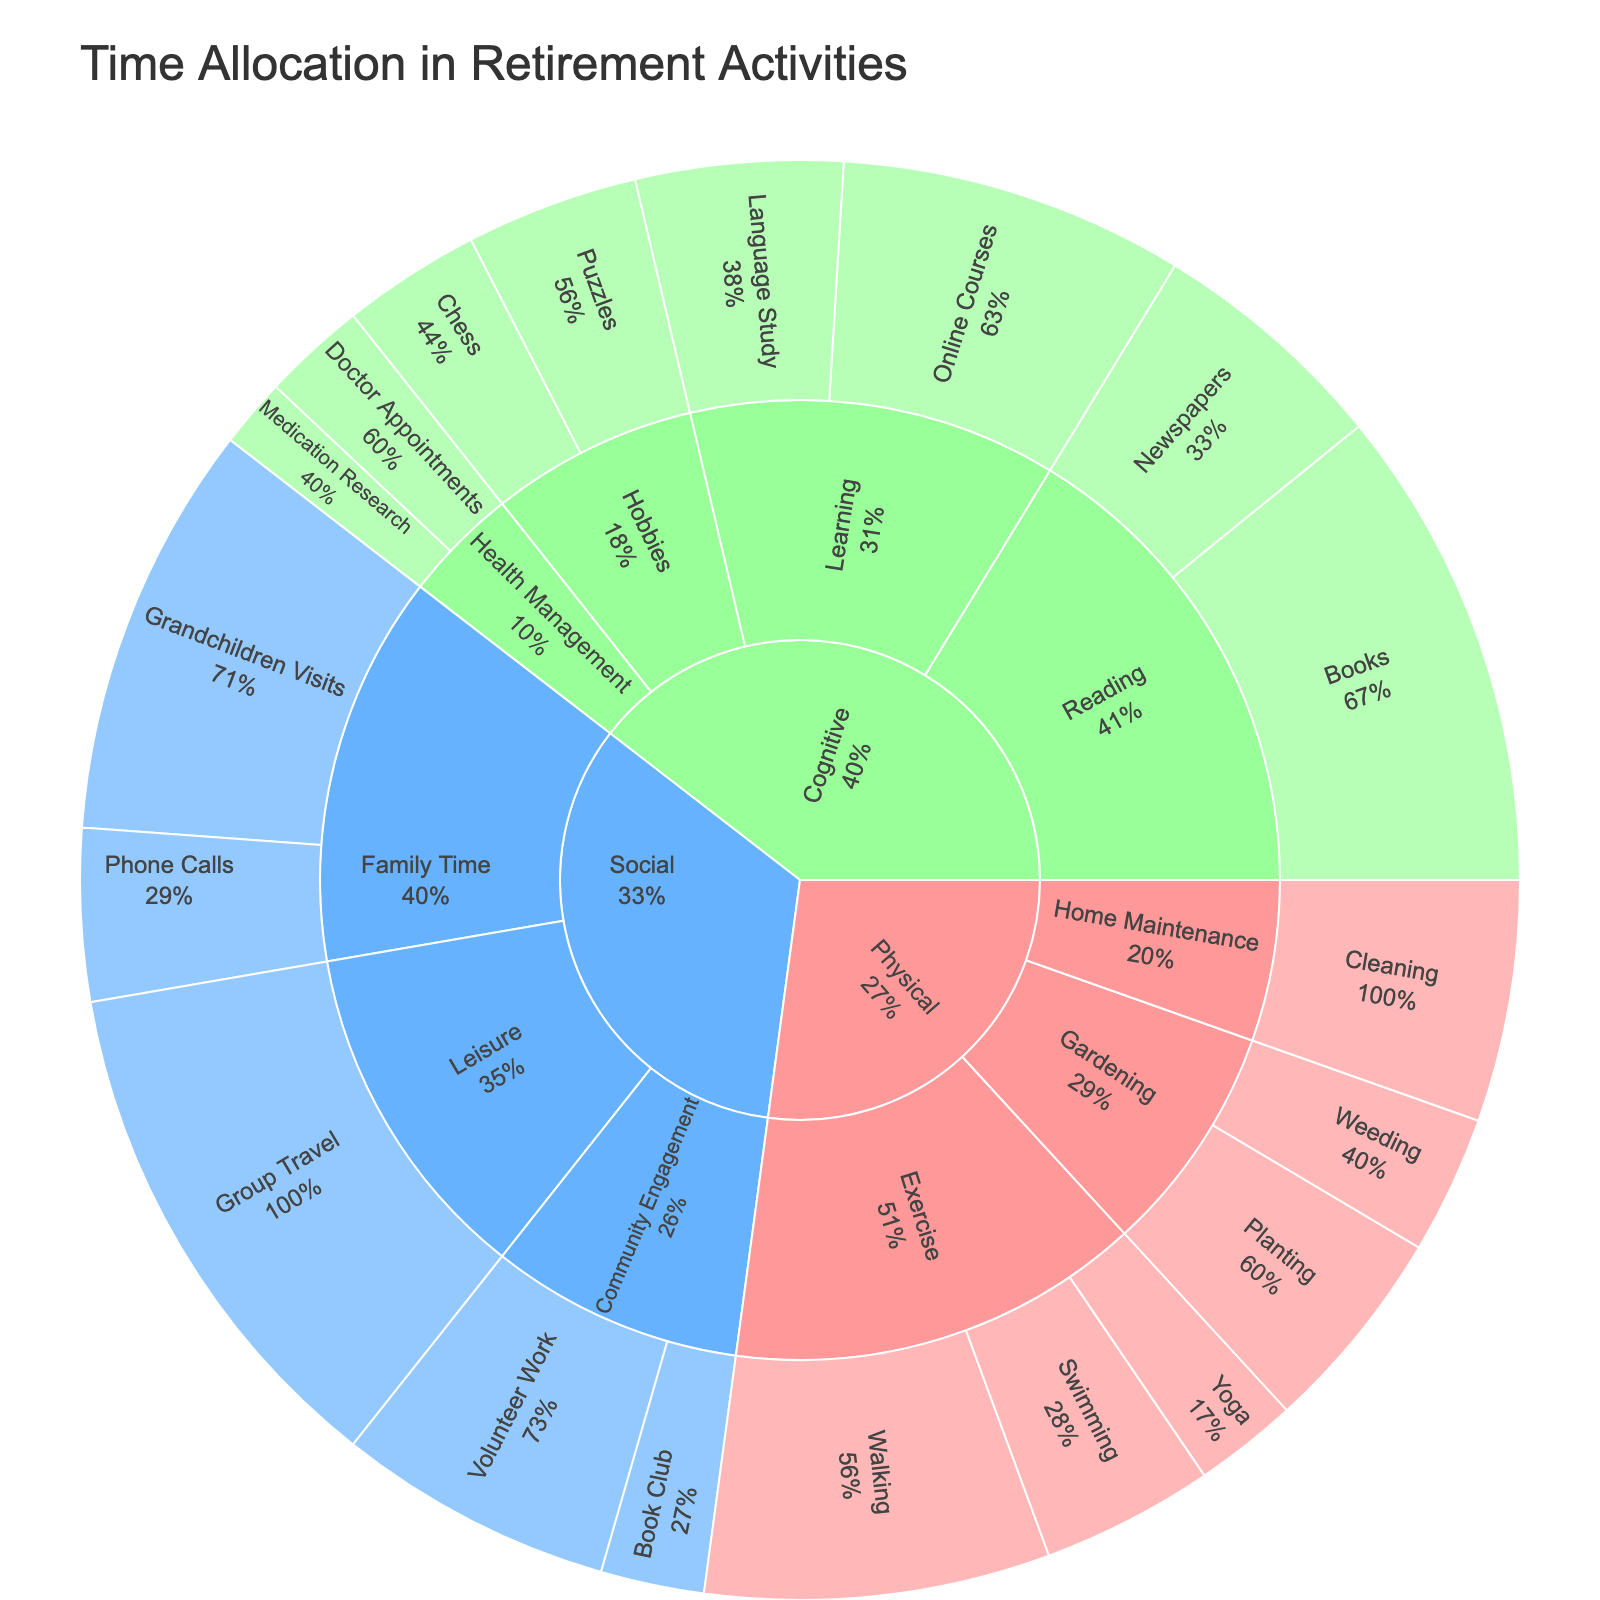What is the main category that allocates the most hours in retirement activities? By looking at the overall structure of the Sunburst Plot, we can identify which main category has the largest section. This will indicate which category allocates the most hours.
Answer: Social How many activities fall under the Cognitive category? First, locate the Cognitive section of the Sunburst Plot. Then, count the number of sub-sections or segments branching out from it, which represent different activities.
Answer: 7 Which activity in the Physical category has the highest number of hours? From the Physical category on the Sunburst Plot, identify which activity segment has the largest size. This will correspond to the activity with the highest number of hours.
Answer: Walking What percentage of time within the Social category is dedicated to Group Travel? Identify the segment for Group Travel under the Social category. Read the corresponding percentage label to determine what per cent of the time for Social activities is allotted to Group Travel.
Answer: 37.5% Compare the hours spent on Online Courses and Books in the Cognitive category, which one is higher? Locate Online Courses and Books in the Cognitive section on the plot. Compare their sizes or hours to determine which activity has a higher value.
Answer: Books What is the total number of hours allocated to Exercise activities? Identify all the segments under Exercise in the Physical category and add their hours: Walking (10), Swimming (5), and Yoga (3). Total = 10 + 5 + 3.
Answer: 18 Does the Gardening subcategory have more hours than the Home Maintenance subcategory in the Physical category? Locate the Gardening and Home Maintenance subcategories under Physical. Compare their total hours: Gardening (Planting 6 + Weeding 4) is 10 hours, and Home Maintenance (Cleaning 7) is 7 hours.
Answer: Yes What's the least time-consuming activity in the Cognitive category? Find the smallest segment in the Cognitive category of the Sunburst Plot. Identify the activity associated with this segment.
Answer: Medication Research Which physical activity has more hours: Swimming or Cleaning? Locate the Swimming and Cleaning activities in the Physical category. Compare their hours directly: Swimming (5), Cleaning (7).
Answer: Cleaning How much more time is spent on Grandchildren Visits compared to Doctor Appointments? Identify Grandchildren Visits (12 hours) and Doctor Appointments (3 hours) from their respective categories and subcategories. Calculate the difference: 12 - 3.
Answer: 9 hours 